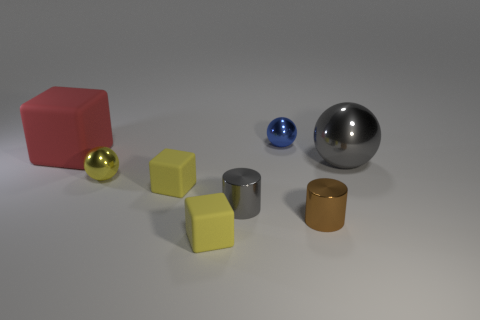Add 1 brown things. How many objects exist? 9 Subtract all blocks. How many objects are left? 5 Subtract all blue matte cylinders. Subtract all brown cylinders. How many objects are left? 7 Add 7 small blue shiny things. How many small blue shiny things are left? 8 Add 8 tiny purple rubber objects. How many tiny purple rubber objects exist? 8 Subtract 0 gray blocks. How many objects are left? 8 